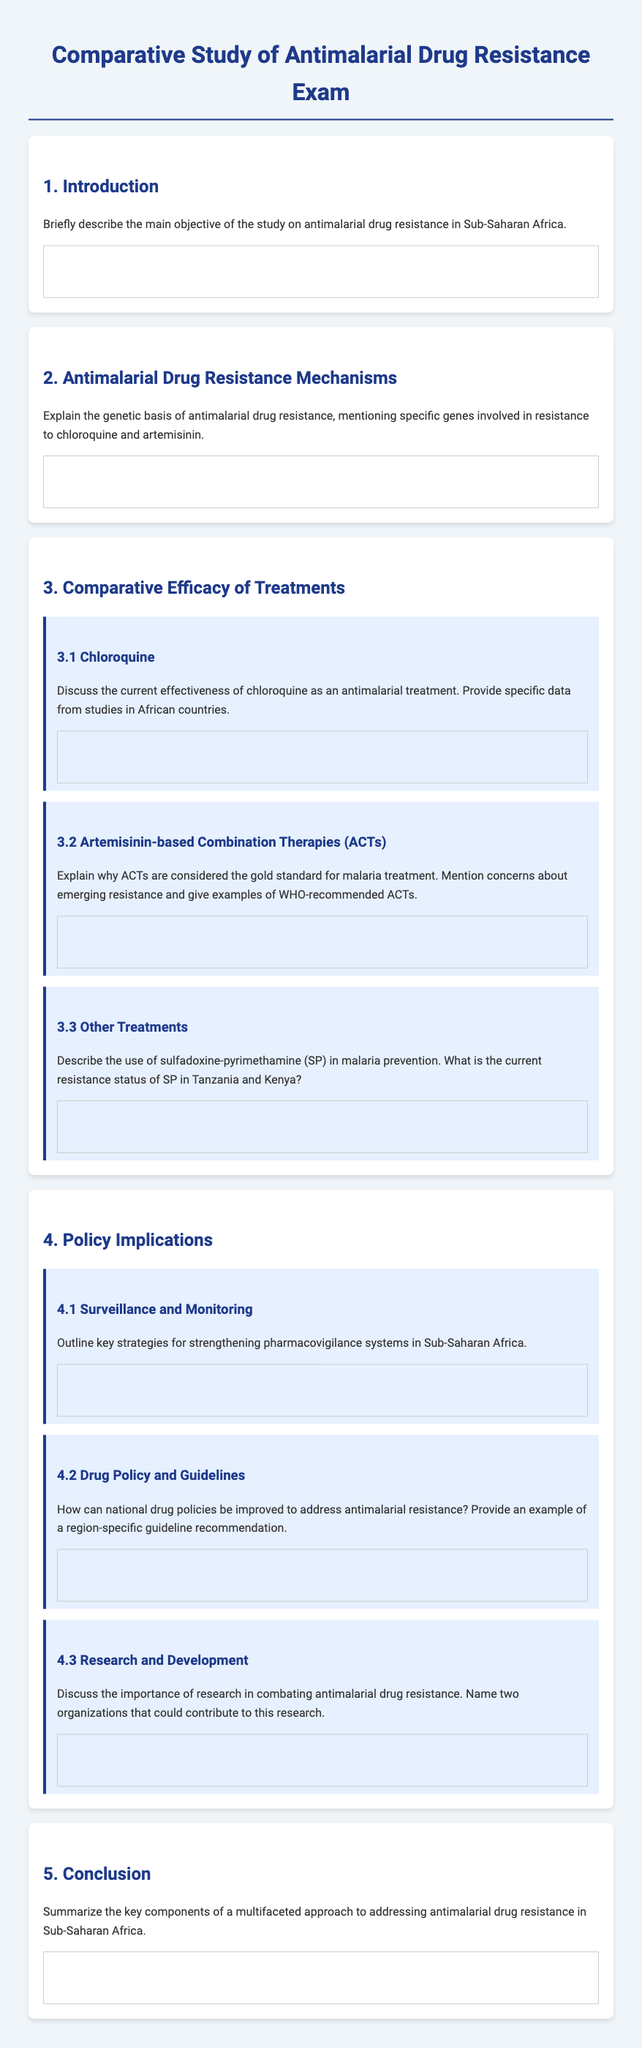what is the main objective of the study? The main objective of the study is to analyze antimalarial drug resistance in Sub-Saharan Africa.
Answer: analyze antimalarial drug resistance in Sub-Saharan Africa which gene is associated with chloroquine resistance? The document mentions specific genes involved in resistance to chloroquine, though details are not provided in the question.
Answer: specific genes why are ACTs considered the gold standard for malaria treatment? The document likely discusses reasons for ACTs being the gold standard, including efficacy and prior resistance.
Answer: efficacy and prior resistance what is the current resistance status of SP in Tanzania? The document provides resistance status details of sulfadoxine-pyrimethamine (SP) in specific countries like Tanzania.
Answer: country-specific resistance status name one key strategy for strengthening pharmacovigilance systems. The document outlines key strategies, though specific ones aren’t mentioned in the question.
Answer: strategies how can national drug policies be improved? The document advises on improving national drug policies with a focus on addressing antimalarial resistance.
Answer: address antimalarial resistance who are two organizations that could contribute to antimalarial research? The document names organizations contributing to research in antimalarial drug resistance within its contents.
Answer: research organizations what are the key components of a multifaceted approach? The conclusion summarizes key components without specifying them in a single statement here.
Answer: multifaceted approach components 